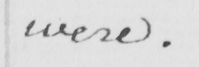What text is written in this handwritten line? were . 